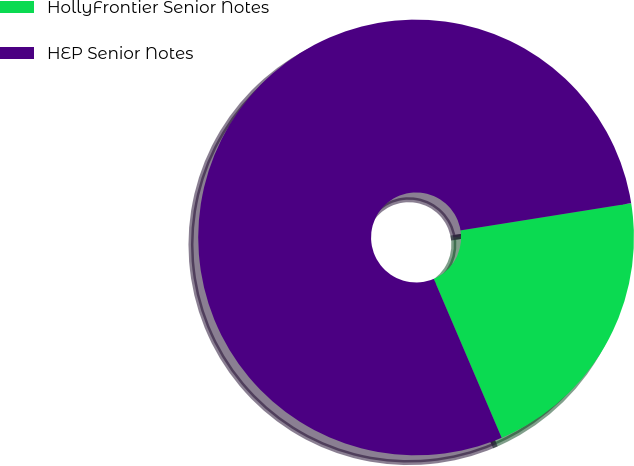Convert chart. <chart><loc_0><loc_0><loc_500><loc_500><pie_chart><fcel>HollyFrontier Senior Notes<fcel>HEP Senior Notes<nl><fcel>21.09%<fcel>78.91%<nl></chart> 